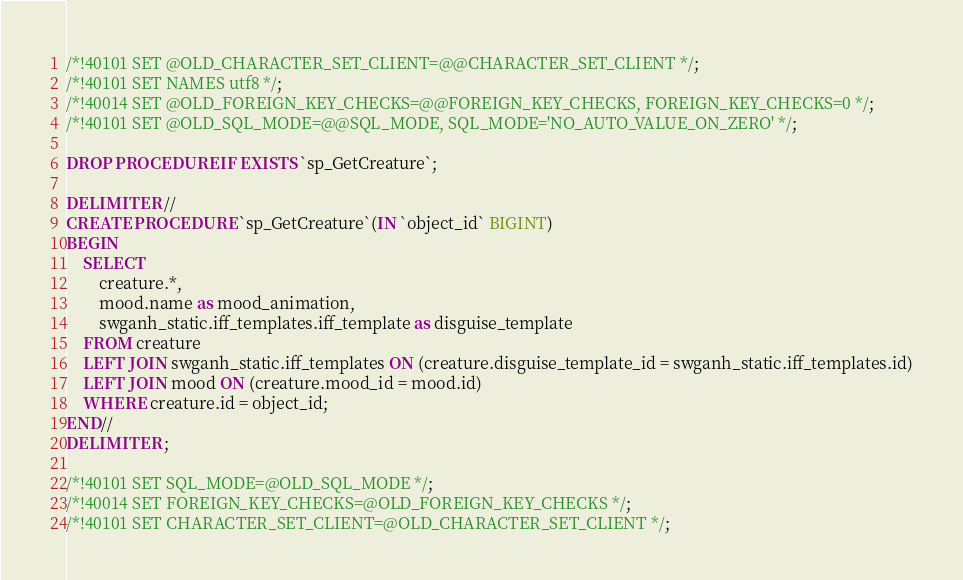Convert code to text. <code><loc_0><loc_0><loc_500><loc_500><_SQL_>
/*!40101 SET @OLD_CHARACTER_SET_CLIENT=@@CHARACTER_SET_CLIENT */;
/*!40101 SET NAMES utf8 */;
/*!40014 SET @OLD_FOREIGN_KEY_CHECKS=@@FOREIGN_KEY_CHECKS, FOREIGN_KEY_CHECKS=0 */;
/*!40101 SET @OLD_SQL_MODE=@@SQL_MODE, SQL_MODE='NO_AUTO_VALUE_ON_ZERO' */;

DROP PROCEDURE IF EXISTS `sp_GetCreature`;

DELIMITER //
CREATE PROCEDURE `sp_GetCreature`(IN `object_id` BIGINT)
BEGIN
    SELECT
        creature.*,
        mood.name as mood_animation,
        swganh_static.iff_templates.iff_template as disguise_template
    FROM creature
    LEFT JOIN swganh_static.iff_templates ON (creature.disguise_template_id = swganh_static.iff_templates.id)
    LEFT JOIN mood ON (creature.mood_id = mood.id)
    WHERE creature.id = object_id;
END//
DELIMITER ;

/*!40101 SET SQL_MODE=@OLD_SQL_MODE */;
/*!40014 SET FOREIGN_KEY_CHECKS=@OLD_FOREIGN_KEY_CHECKS */;
/*!40101 SET CHARACTER_SET_CLIENT=@OLD_CHARACTER_SET_CLIENT */;
</code> 